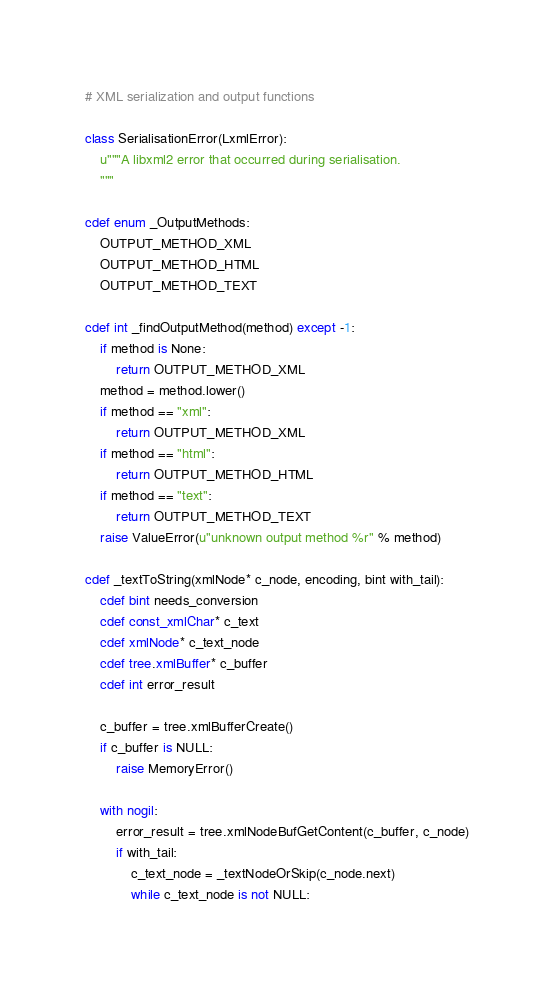Convert code to text. <code><loc_0><loc_0><loc_500><loc_500><_Cython_># XML serialization and output functions

class SerialisationError(LxmlError):
    u"""A libxml2 error that occurred during serialisation.
    """

cdef enum _OutputMethods:
    OUTPUT_METHOD_XML
    OUTPUT_METHOD_HTML
    OUTPUT_METHOD_TEXT

cdef int _findOutputMethod(method) except -1:
    if method is None:
        return OUTPUT_METHOD_XML
    method = method.lower()
    if method == "xml":
        return OUTPUT_METHOD_XML
    if method == "html":
        return OUTPUT_METHOD_HTML
    if method == "text":
        return OUTPUT_METHOD_TEXT
    raise ValueError(u"unknown output method %r" % method)

cdef _textToString(xmlNode* c_node, encoding, bint with_tail):
    cdef bint needs_conversion
    cdef const_xmlChar* c_text
    cdef xmlNode* c_text_node
    cdef tree.xmlBuffer* c_buffer
    cdef int error_result

    c_buffer = tree.xmlBufferCreate()
    if c_buffer is NULL:
        raise MemoryError()

    with nogil:
        error_result = tree.xmlNodeBufGetContent(c_buffer, c_node)
        if with_tail:
            c_text_node = _textNodeOrSkip(c_node.next)
            while c_text_node is not NULL:</code> 